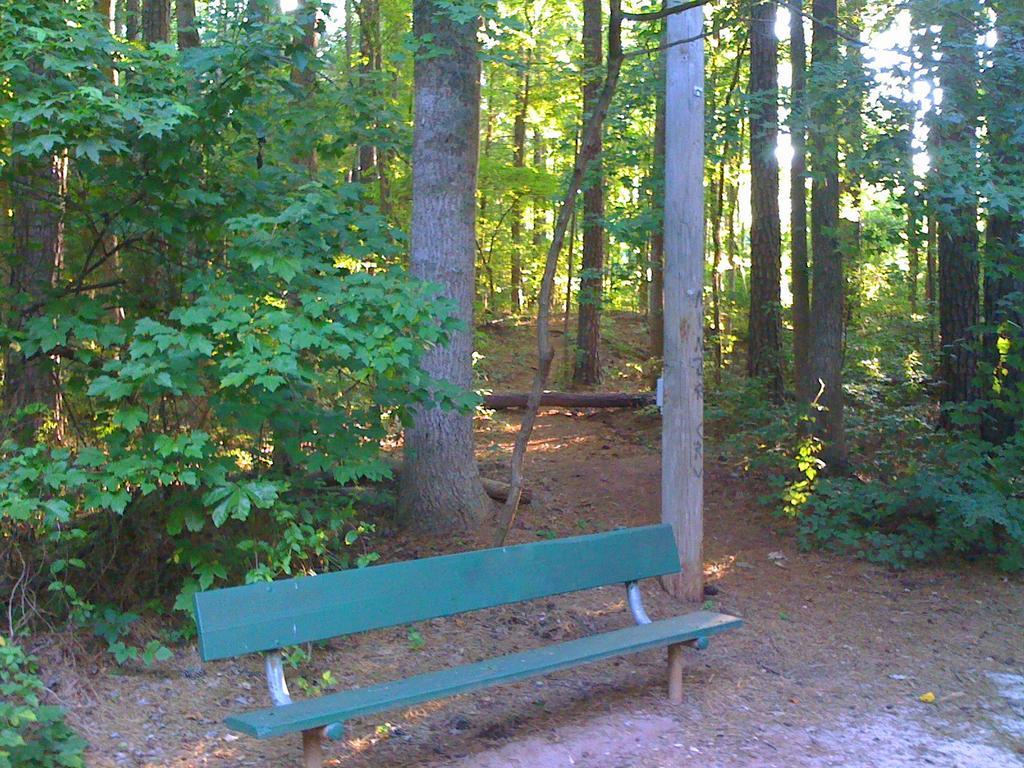Can you describe this image briefly? In this image we can see many trees and few plants. There is a bench in the image. 